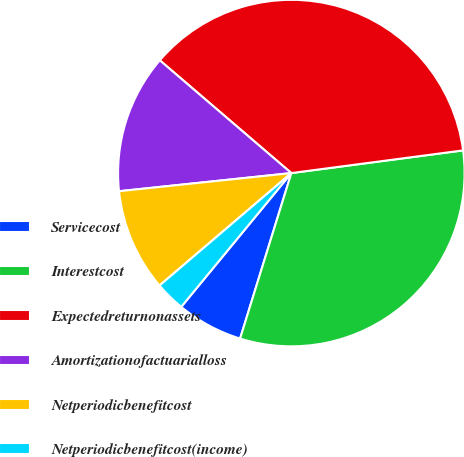Convert chart. <chart><loc_0><loc_0><loc_500><loc_500><pie_chart><fcel>Servicecost<fcel>Interestcost<fcel>Expectedreturnonassets<fcel>Amortizationofactuarialloss<fcel>Netperiodicbenefitcost<fcel>Netperiodicbenefitcost(income)<nl><fcel>6.18%<fcel>31.87%<fcel>36.63%<fcel>12.95%<fcel>9.57%<fcel>2.8%<nl></chart> 